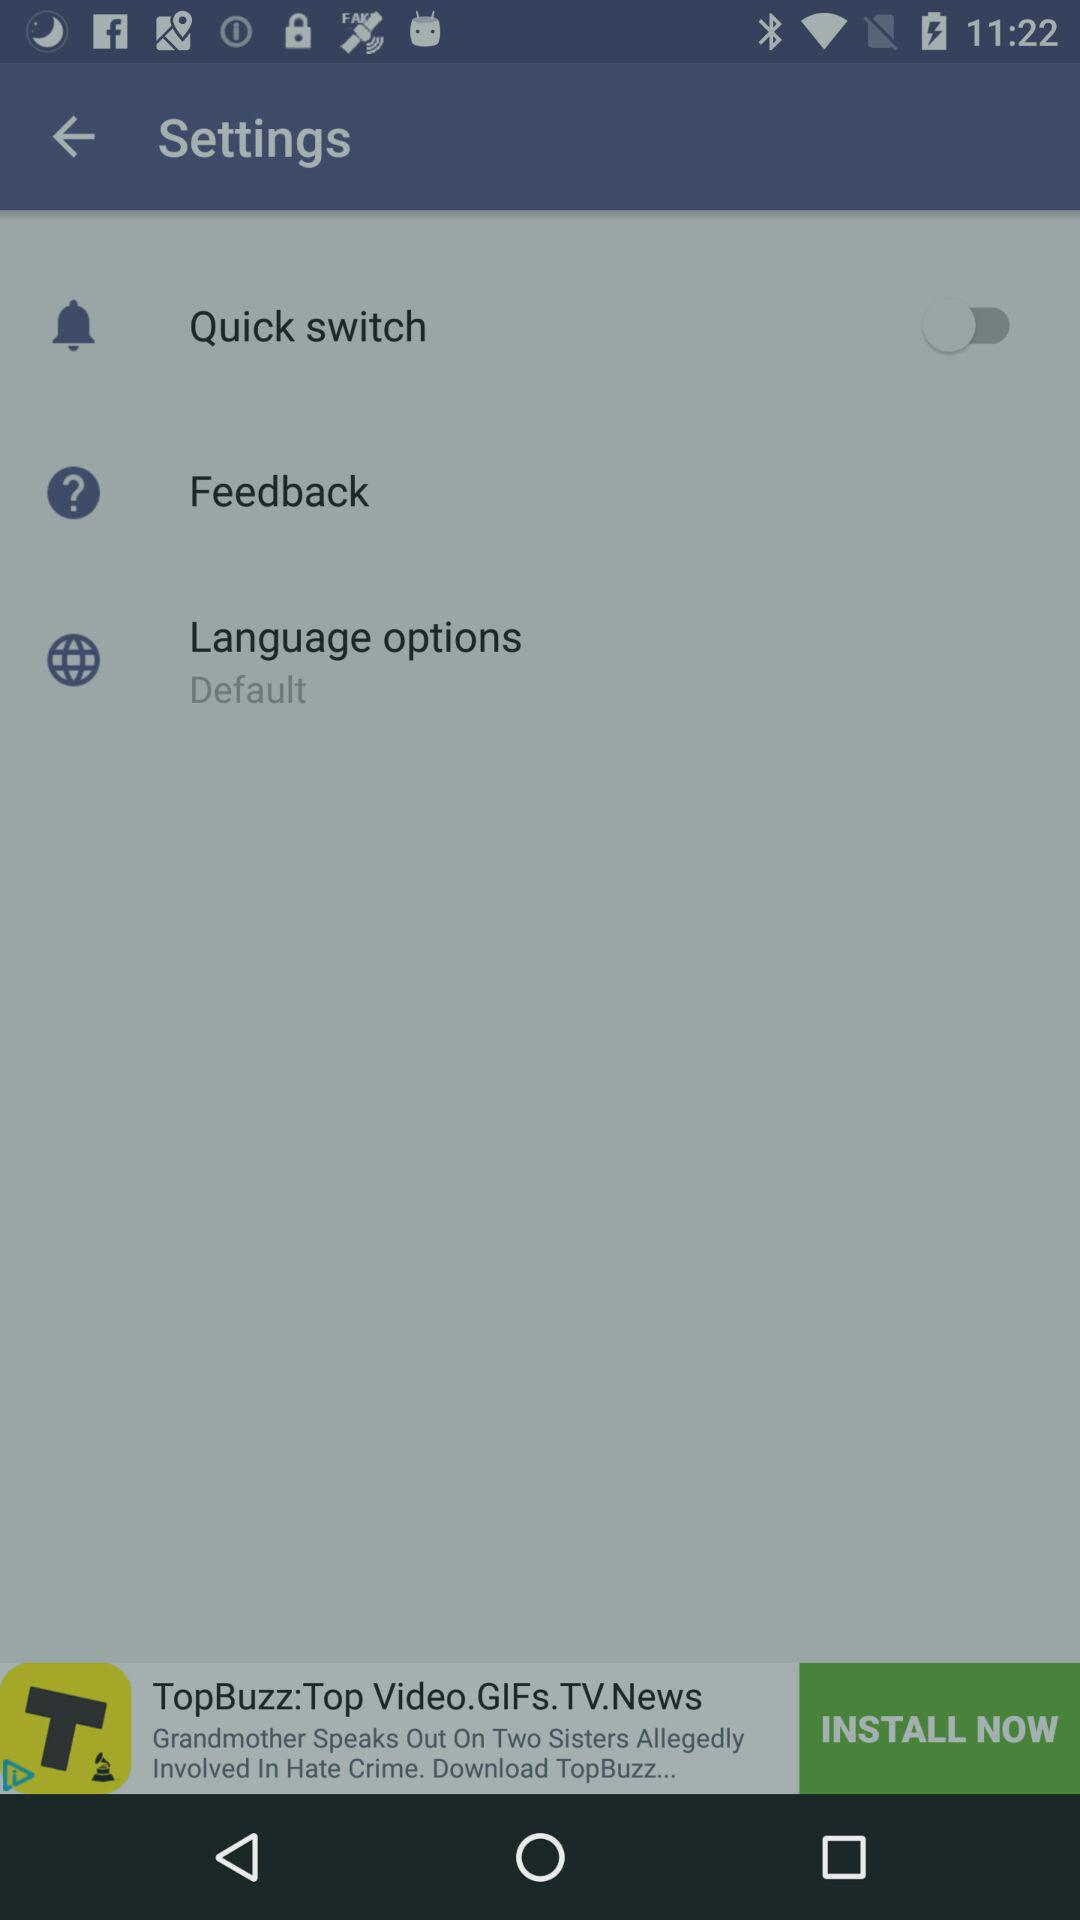Is "Feedback" checked or unchecked?
When the provided information is insufficient, respond with <no answer>. <no answer> 